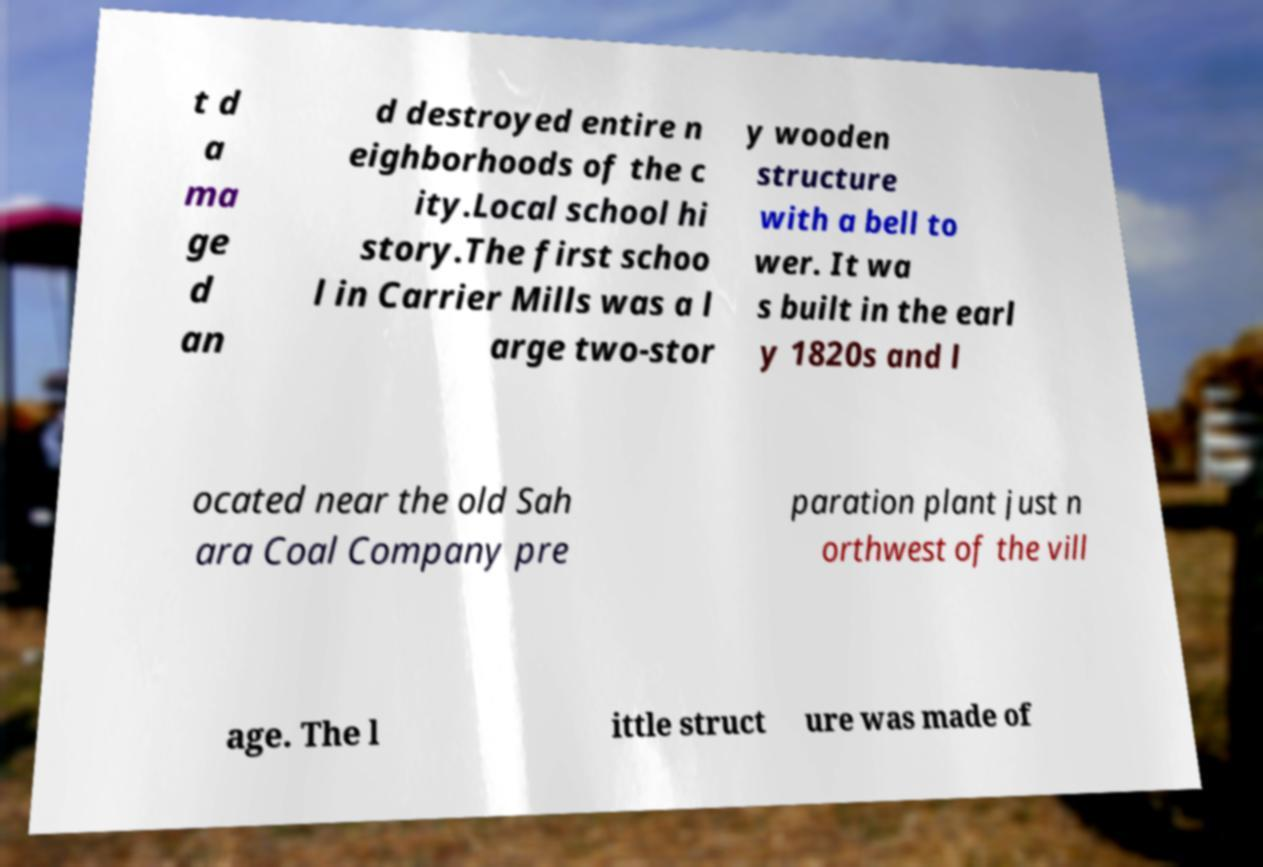For documentation purposes, I need the text within this image transcribed. Could you provide that? t d a ma ge d an d destroyed entire n eighborhoods of the c ity.Local school hi story.The first schoo l in Carrier Mills was a l arge two-stor y wooden structure with a bell to wer. It wa s built in the earl y 1820s and l ocated near the old Sah ara Coal Company pre paration plant just n orthwest of the vill age. The l ittle struct ure was made of 